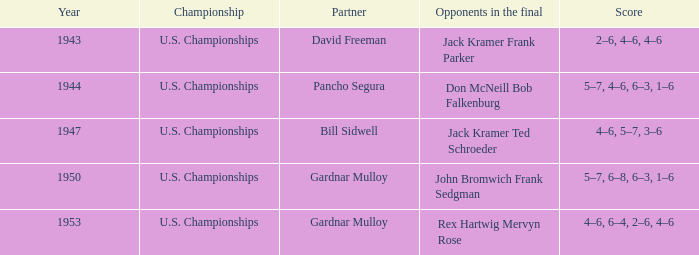During which year were the results 5-7, 4-6, 6-3, and 1-6 recorded? 1944.0. 